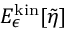<formula> <loc_0><loc_0><loc_500><loc_500>E _ { \epsilon } ^ { k i n } [ \tilde { \eta } ]</formula> 